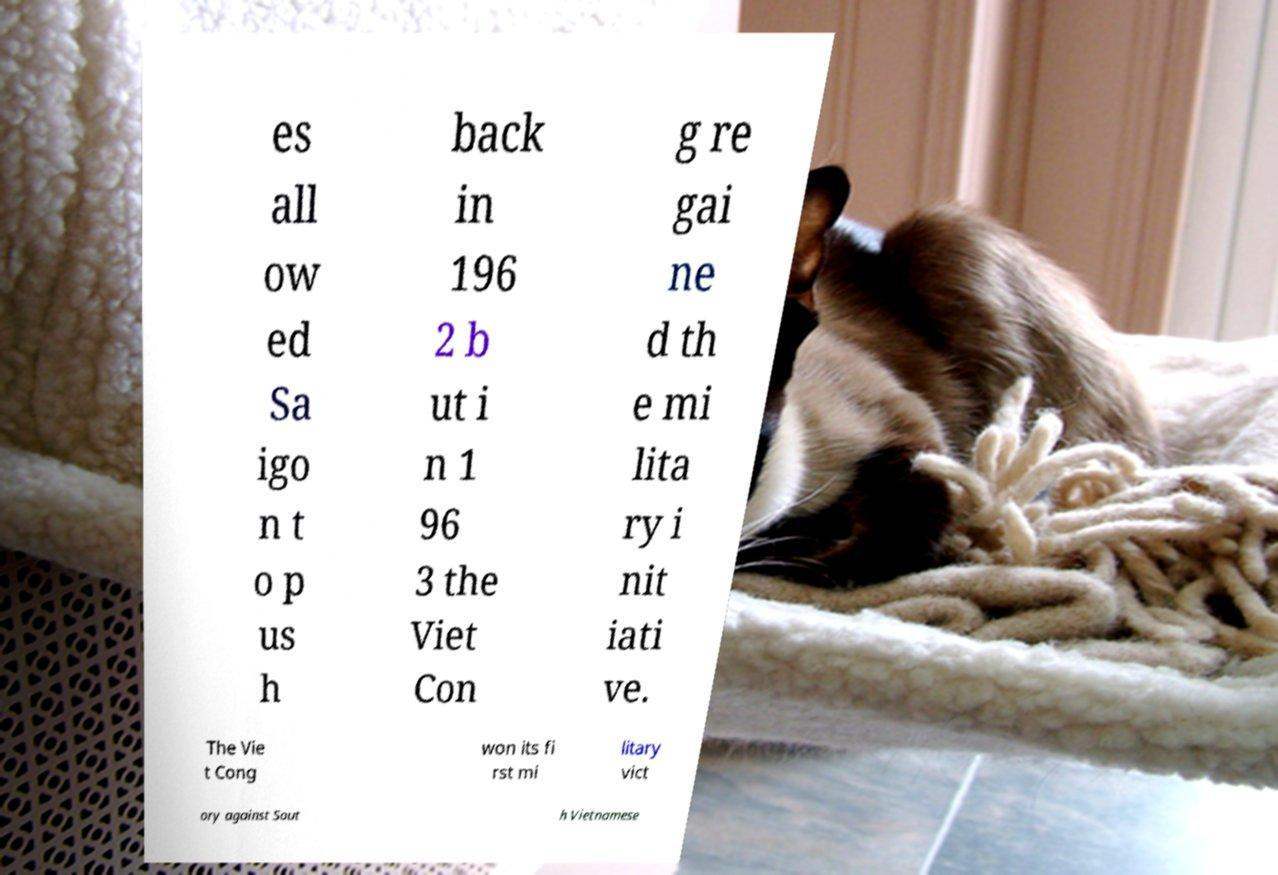Can you accurately transcribe the text from the provided image for me? es all ow ed Sa igo n t o p us h back in 196 2 b ut i n 1 96 3 the Viet Con g re gai ne d th e mi lita ry i nit iati ve. The Vie t Cong won its fi rst mi litary vict ory against Sout h Vietnamese 